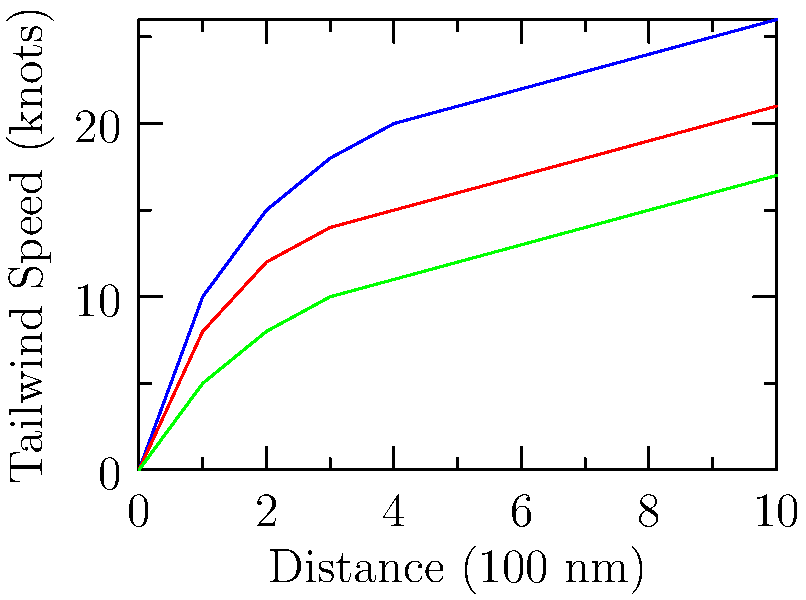Given the wind pattern data shown in the graph for different altitudes, which altitude would provide the optimal flight path for a long-distance flight heading east? Consider that fuel efficiency typically increases with altitude, but the aircraft's maximum operating altitude is 30,000 ft. To determine the optimal altitude for the flight path, we need to consider both the tailwind speed and fuel efficiency:

1. Analyze the tailwind speeds:
   - 30,000 ft (blue line): Highest tailwind speeds, reaching 26 knots
   - 25,000 ft (red line): Medium tailwind speeds, reaching 21 knots
   - 20,000 ft (green line): Lowest tailwind speeds, reaching 17 knots

2. Consider fuel efficiency:
   - Fuel efficiency typically increases with altitude due to thinner air and reduced drag.

3. Evaluate the trade-offs:
   - The 30,000 ft altitude provides the strongest tailwinds, which would reduce flight time and fuel consumption.
   - It also aligns with the principle of increased fuel efficiency at higher altitudes.
   - The aircraft's maximum operating altitude of 30,000 ft allows for this flight level.

4. Make the decision:
   - The 30,000 ft altitude offers the best combination of strong tailwinds and fuel efficiency.
   - It's within the aircraft's operating limits.

Therefore, the optimal altitude for this long-distance flight heading east would be 30,000 ft.
Answer: 30,000 ft 